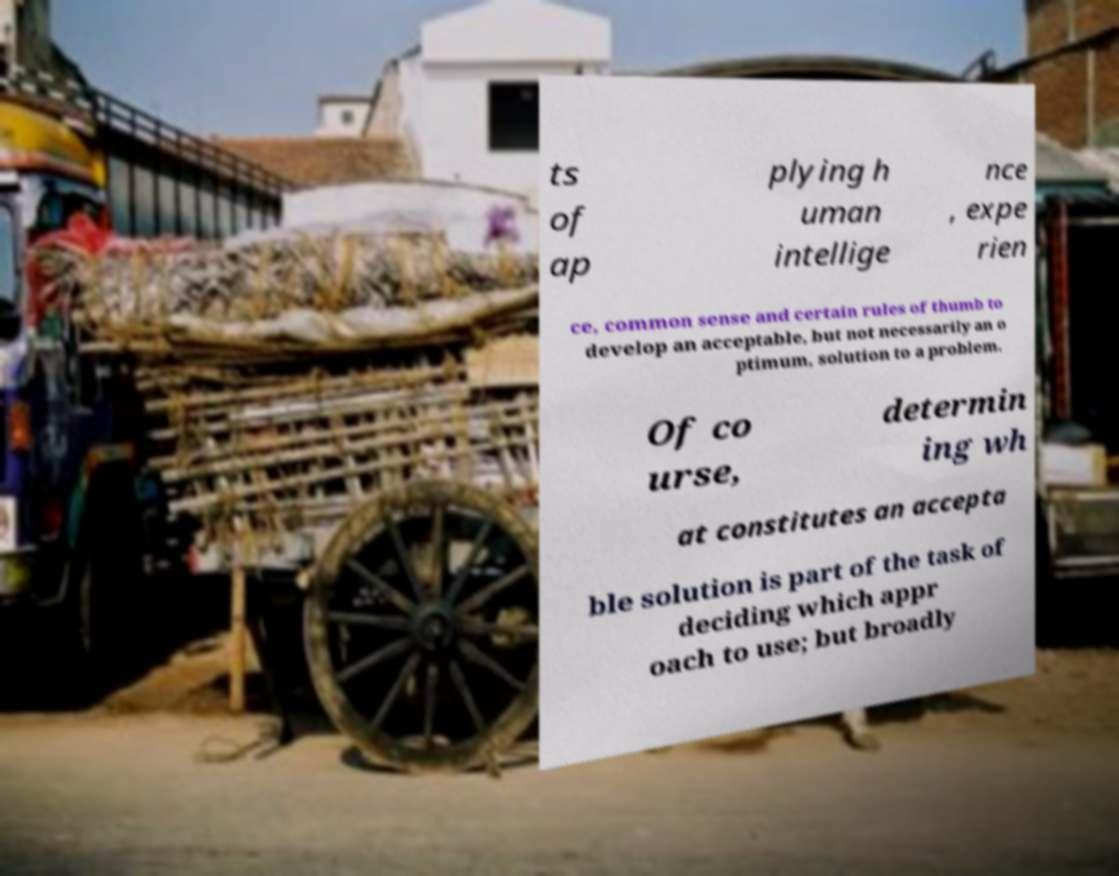I need the written content from this picture converted into text. Can you do that? ts of ap plying h uman intellige nce , expe rien ce, common sense and certain rules of thumb to develop an acceptable, but not necessarily an o ptimum, solution to a problem. Of co urse, determin ing wh at constitutes an accepta ble solution is part of the task of deciding which appr oach to use; but broadly 